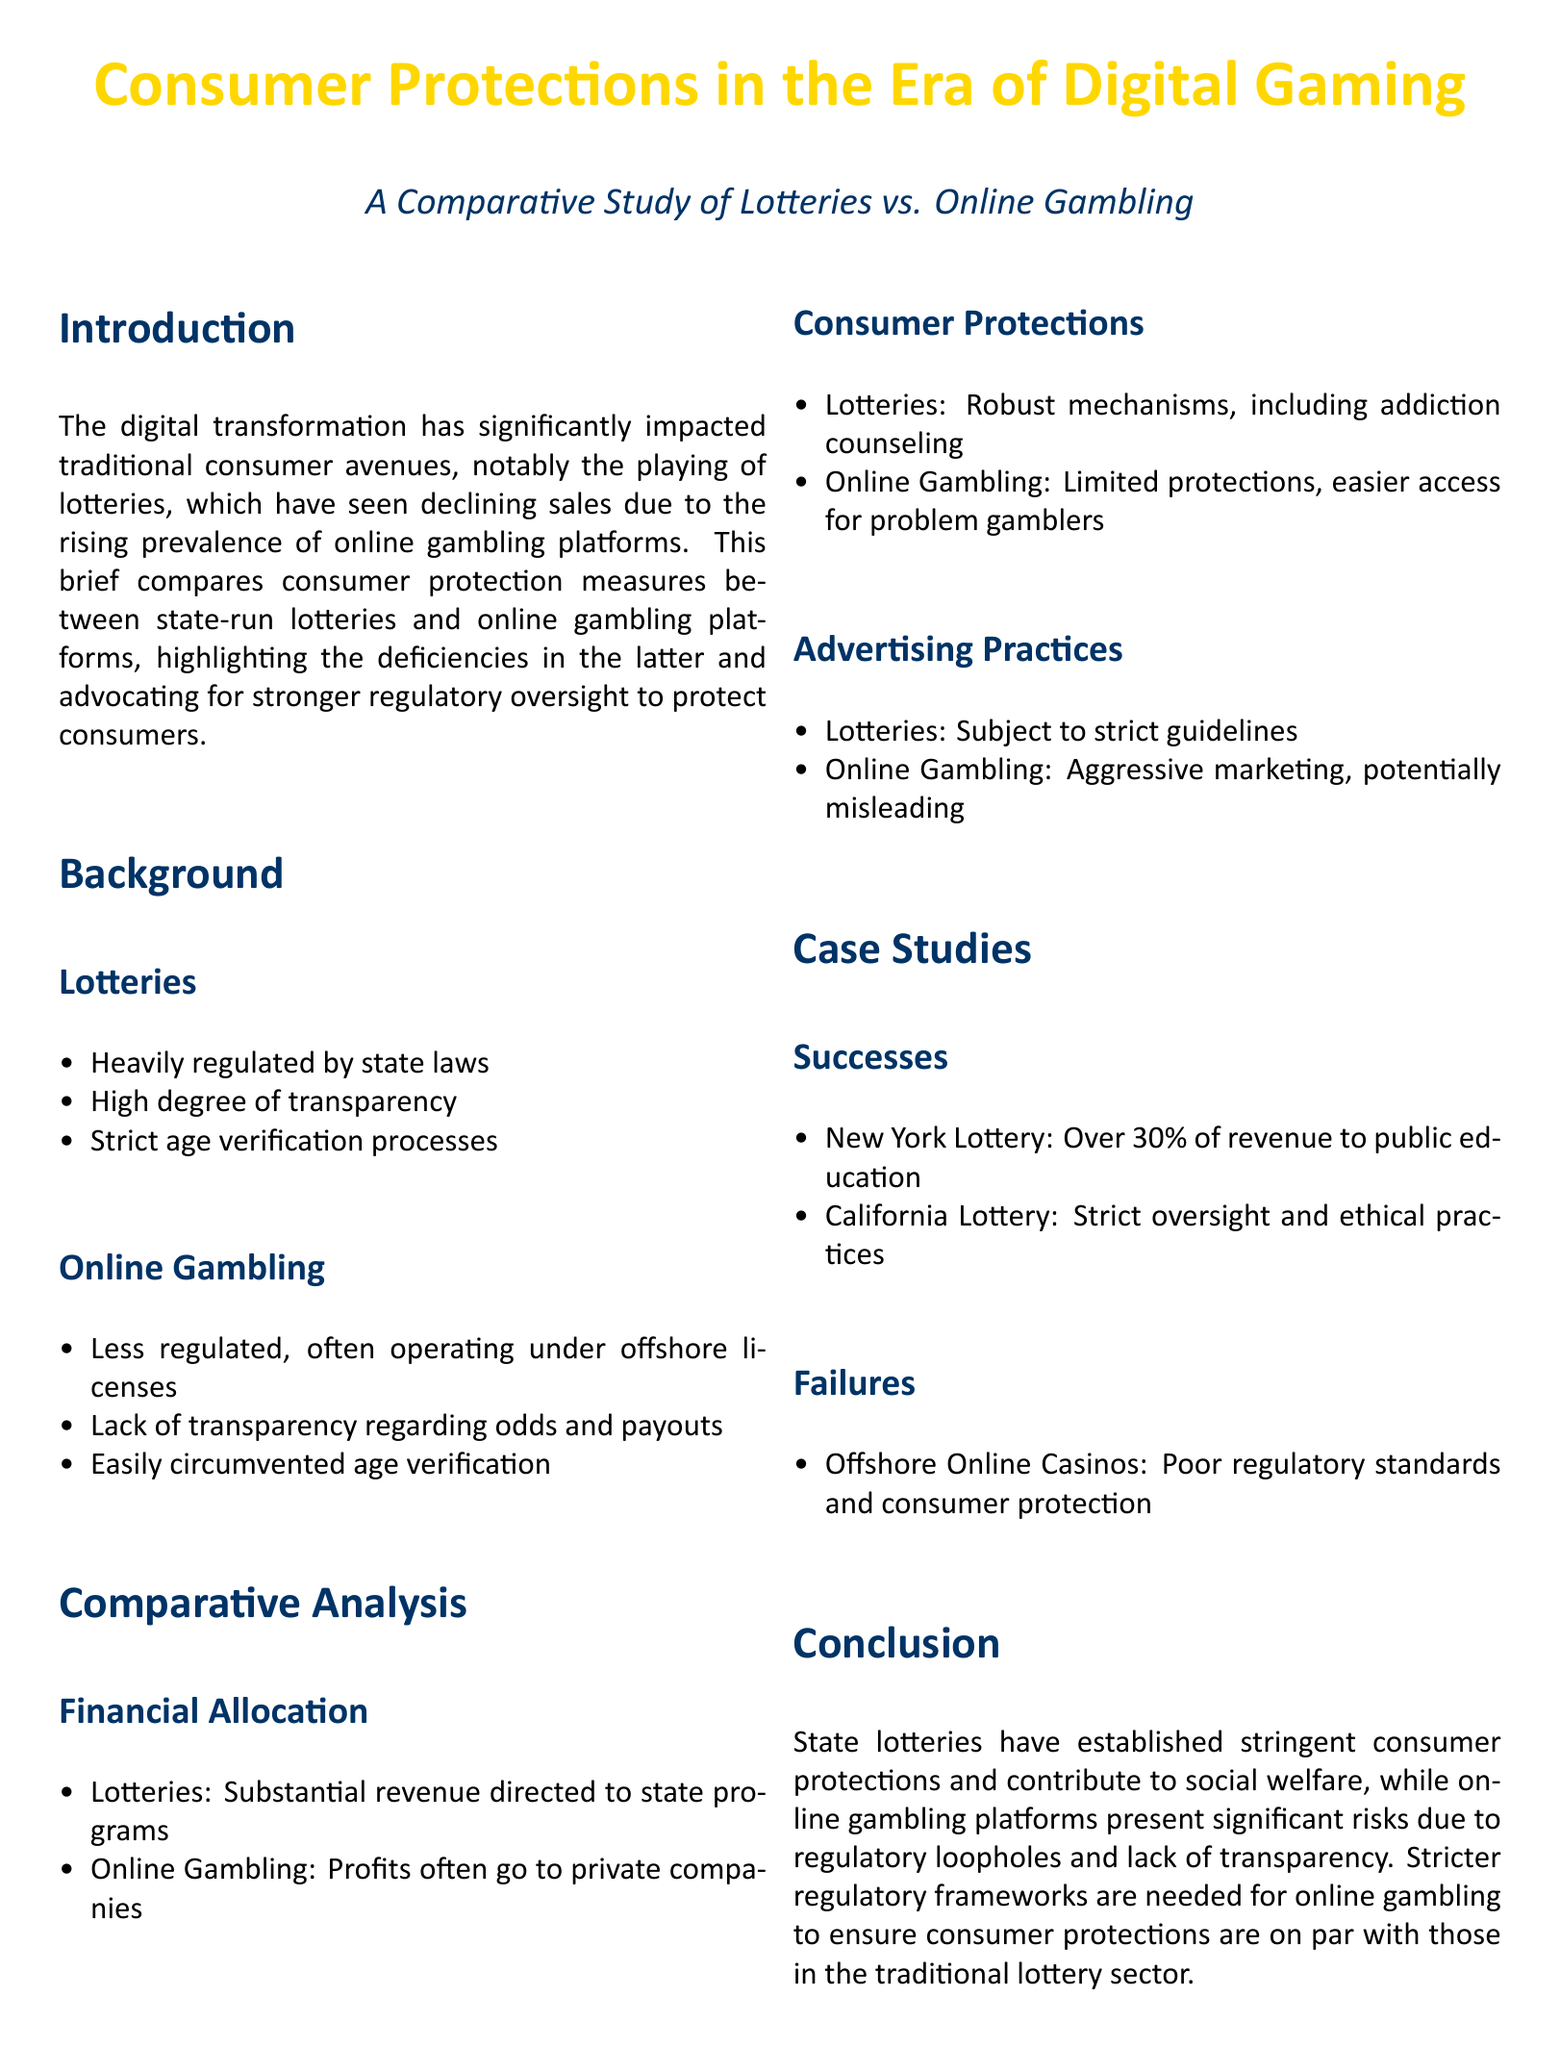What are the two main subjects of the study? The study compares consumer protections of state-run lotteries and online gambling platforms.
Answer: Lotteries and online gambling What percentage of revenue does the New York Lottery allocate to public education? The New York Lottery allocates over 30% of its revenue to public education.
Answer: Over 30% What are lotteries required to have for age verification? Lotteries have strict age verification processes.
Answer: Strict age verification processes What do online gambling platforms operate under that affects regulation? Online gambling platforms often operate under offshore licenses.
Answer: Offshore licenses What is one major failure mentioned related to offshore online casinos? Offshore online casinos face poor regulatory standards and consumer protection.
Answer: Poor regulatory standards and consumer protection What type of marketing practices do online gambling platforms use? Online gambling platforms employ aggressive marketing practices that may be misleading.
Answer: Aggressive marketing What is the concluding call to action in the document? The document advocates for stricter regulatory frameworks for online gambling.
Answer: Stricter regulatory frameworks What do lotteries significantly contribute to? Lotteries contribute to social welfare through revenue allocation to state programs.
Answer: Social welfare What is a consumer protection measure that lotteries have that online gambling lacks? Lotteries have robust mechanisms, including addiction counseling.
Answer: Addiction counseling 